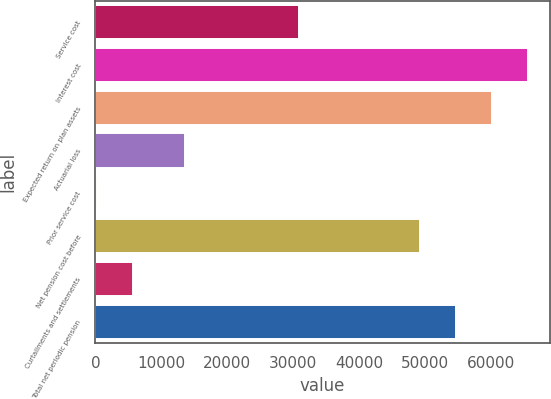<chart> <loc_0><loc_0><loc_500><loc_500><bar_chart><fcel>Service cost<fcel>Interest cost<fcel>Expected return on plan assets<fcel>Actuarial loss<fcel>Prior service cost<fcel>Net pension cost before<fcel>Curtailments and settlements<fcel>Total net periodic pension<nl><fcel>30816<fcel>65550.4<fcel>60117.6<fcel>13535<fcel>303<fcel>49252<fcel>5735.8<fcel>54684.8<nl></chart> 